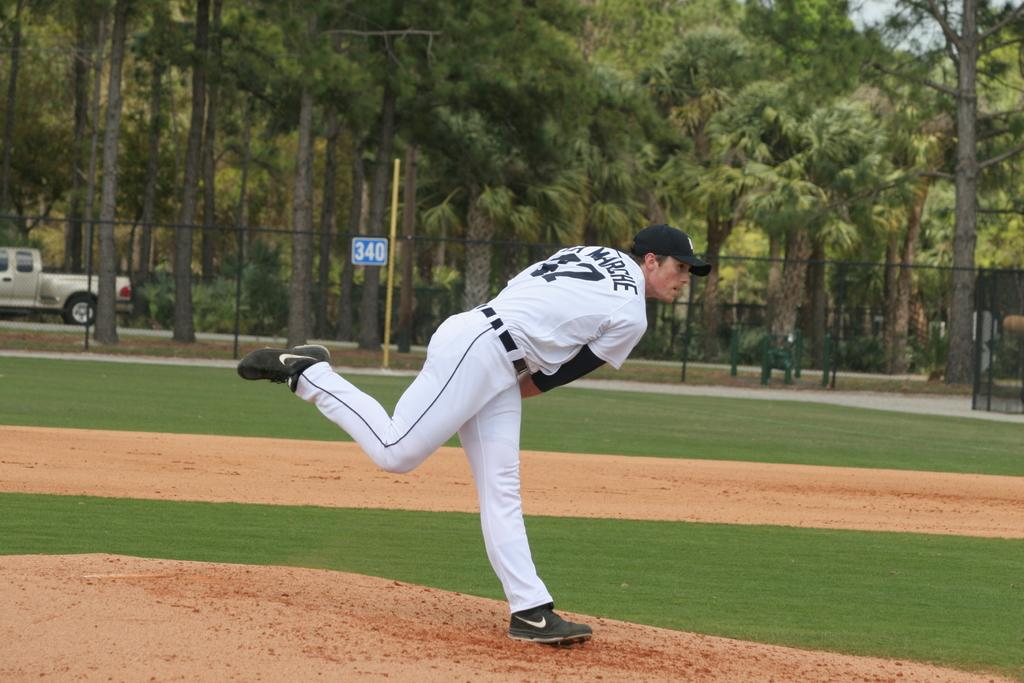Provide a one-sentence caption for the provided image. Blue and white sign with number 340 on a black fence. 